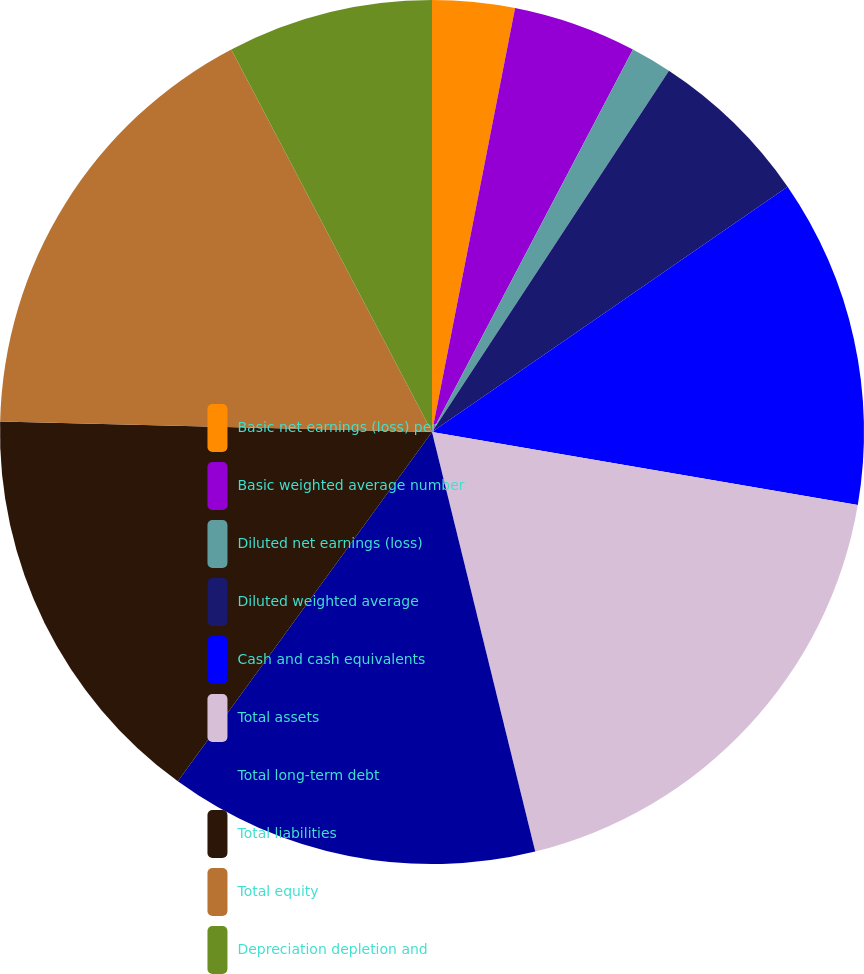Convert chart to OTSL. <chart><loc_0><loc_0><loc_500><loc_500><pie_chart><fcel>Basic net earnings (loss) per<fcel>Basic weighted average number<fcel>Diluted net earnings (loss)<fcel>Diluted weighted average<fcel>Cash and cash equivalents<fcel>Total assets<fcel>Total long-term debt<fcel>Total liabilities<fcel>Total equity<fcel>Depreciation depletion and<nl><fcel>3.08%<fcel>4.62%<fcel>1.54%<fcel>6.15%<fcel>12.31%<fcel>18.46%<fcel>13.85%<fcel>15.38%<fcel>16.92%<fcel>7.69%<nl></chart> 